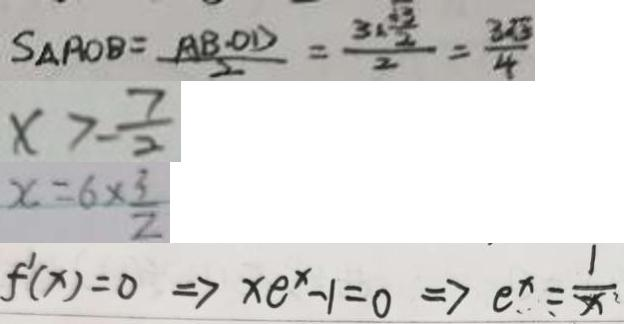<formula> <loc_0><loc_0><loc_500><loc_500>S _ { \Delta } R O B = \frac { A B \cdot O D } { 2 } = \frac { 3 \times \frac { \sqrt { 3 } } { 2 } } { 2 } = \frac { 3 \sqrt { 3 } } { 4 } 
 x > - \frac { 7 } { 2 } 
 x = 6 \times \frac { 3 } { 2 } 
 f ^ { \prime } ( x ) = 0 \Rightarrow x e ^ { x } - 1 = 0 \Rightarrow e ^ { x } = \frac { 1 } { x }</formula> 